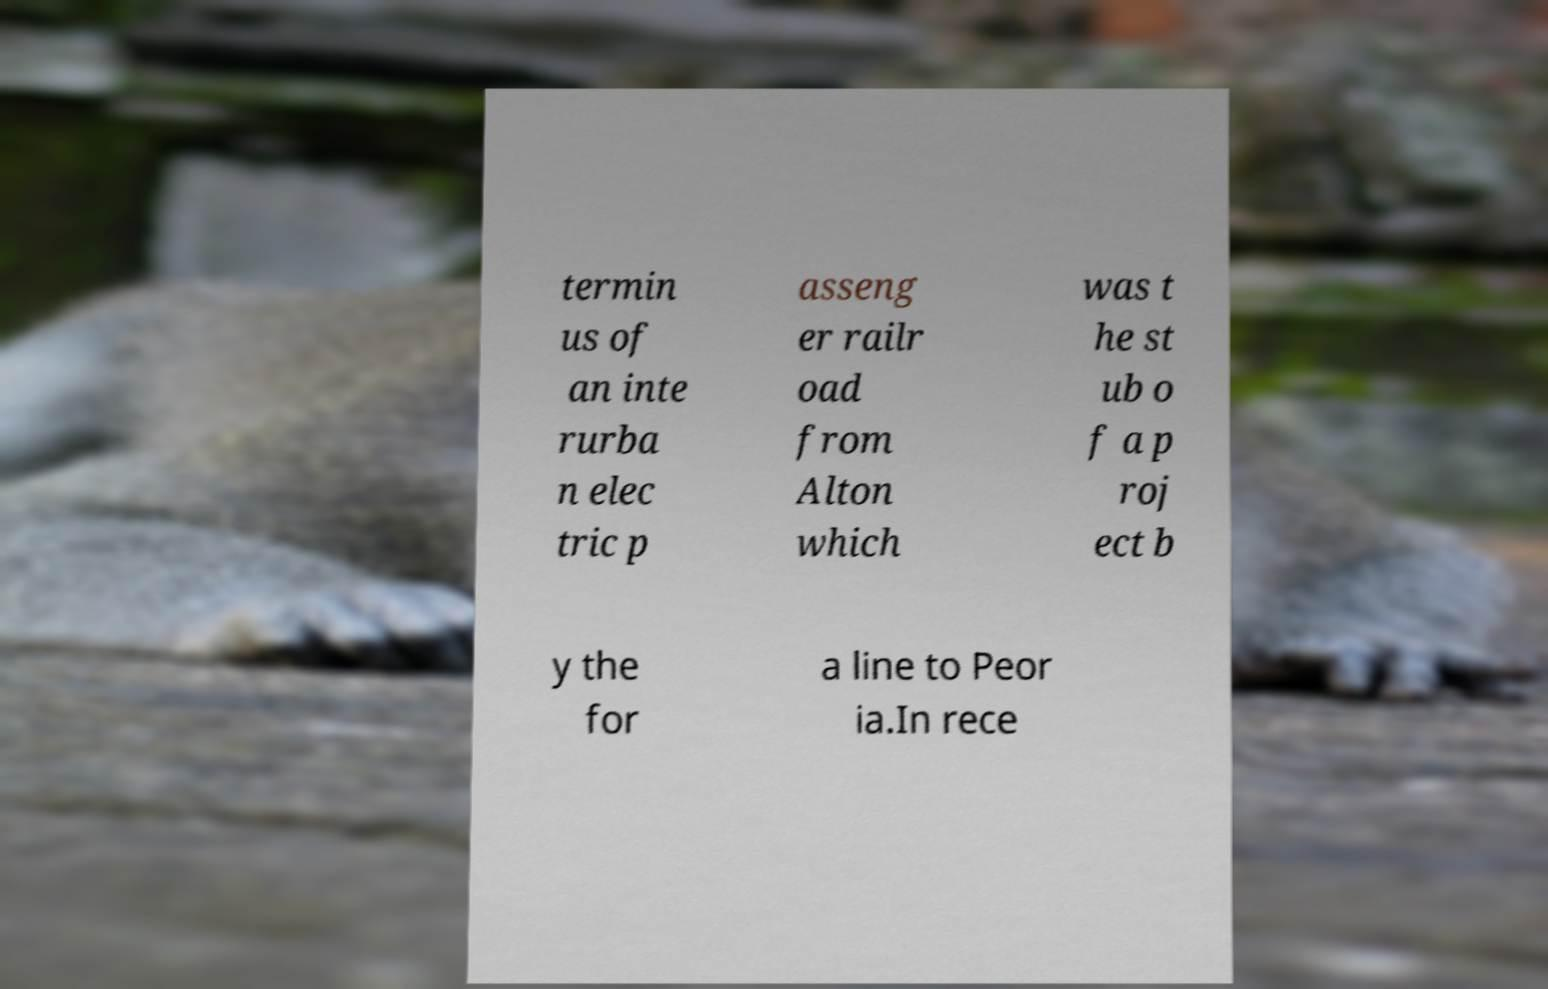Please read and relay the text visible in this image. What does it say? termin us of an inte rurba n elec tric p asseng er railr oad from Alton which was t he st ub o f a p roj ect b y the for a line to Peor ia.In rece 